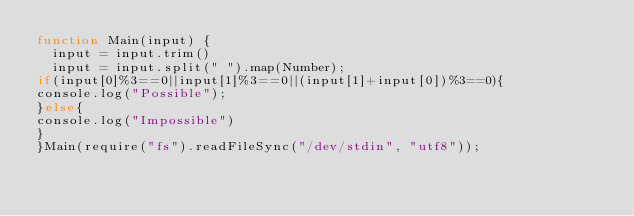Convert code to text. <code><loc_0><loc_0><loc_500><loc_500><_JavaScript_>function Main(input) {
  input = input.trim()
  input = input.split(" ").map(Number);
if(input[0]%3==0||input[1]%3==0||(input[1]+input[0])%3==0){
console.log("Possible");
}else{
console.log("Impossible")
}
}Main(require("fs").readFileSync("/dev/stdin", "utf8"));</code> 